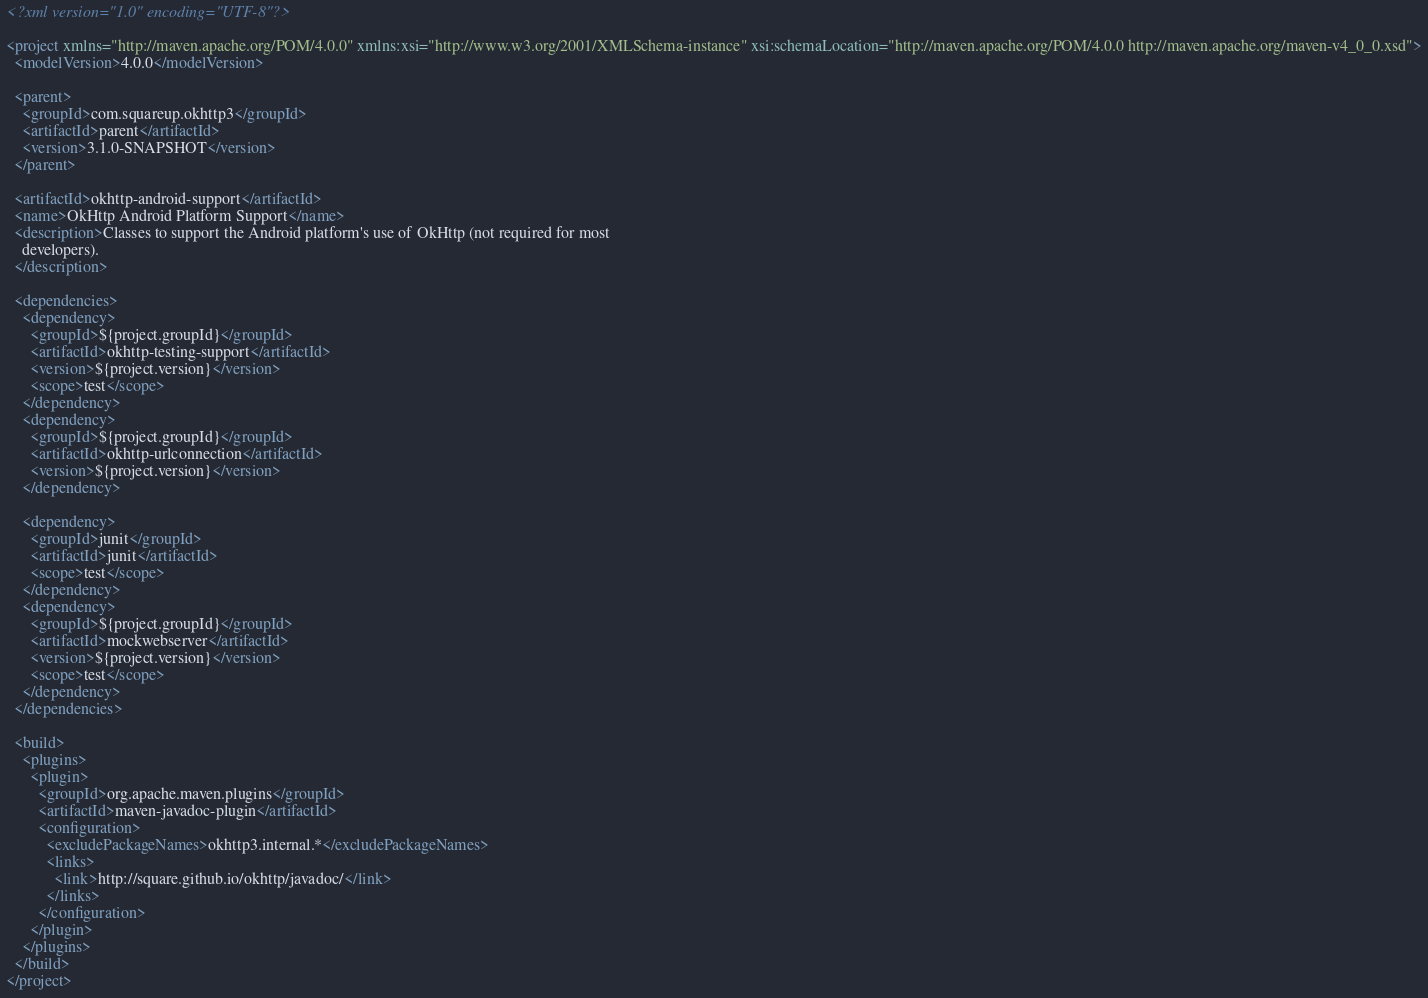<code> <loc_0><loc_0><loc_500><loc_500><_XML_><?xml version="1.0" encoding="UTF-8"?>

<project xmlns="http://maven.apache.org/POM/4.0.0" xmlns:xsi="http://www.w3.org/2001/XMLSchema-instance" xsi:schemaLocation="http://maven.apache.org/POM/4.0.0 http://maven.apache.org/maven-v4_0_0.xsd">
  <modelVersion>4.0.0</modelVersion>

  <parent>
    <groupId>com.squareup.okhttp3</groupId>
    <artifactId>parent</artifactId>
    <version>3.1.0-SNAPSHOT</version>
  </parent>

  <artifactId>okhttp-android-support</artifactId>
  <name>OkHttp Android Platform Support</name>
  <description>Classes to support the Android platform's use of OkHttp (not required for most
    developers).
  </description>

  <dependencies>
    <dependency>
      <groupId>${project.groupId}</groupId>
      <artifactId>okhttp-testing-support</artifactId>
      <version>${project.version}</version>
      <scope>test</scope>
    </dependency>
    <dependency>
      <groupId>${project.groupId}</groupId>
      <artifactId>okhttp-urlconnection</artifactId>
      <version>${project.version}</version>
    </dependency>

    <dependency>
      <groupId>junit</groupId>
      <artifactId>junit</artifactId>
      <scope>test</scope>
    </dependency>
    <dependency>
      <groupId>${project.groupId}</groupId>
      <artifactId>mockwebserver</artifactId>
      <version>${project.version}</version>
      <scope>test</scope>
    </dependency>
  </dependencies>

  <build>
    <plugins>
      <plugin>
        <groupId>org.apache.maven.plugins</groupId>
        <artifactId>maven-javadoc-plugin</artifactId>
        <configuration>
          <excludePackageNames>okhttp3.internal.*</excludePackageNames>
          <links>
            <link>http://square.github.io/okhttp/javadoc/</link>
          </links>
        </configuration>
      </plugin>
    </plugins>
  </build>
</project>
</code> 